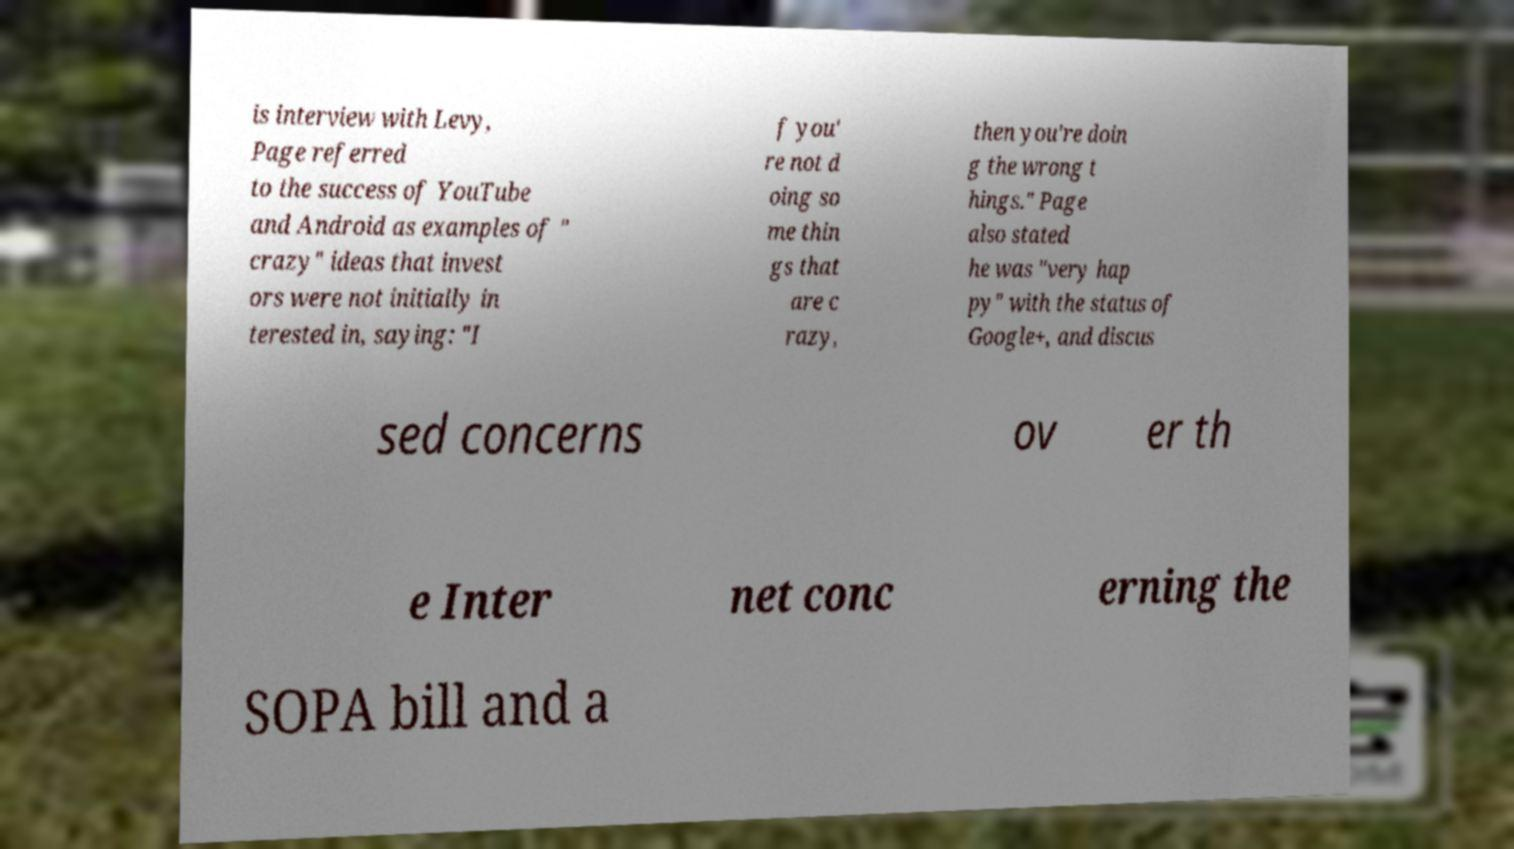Please identify and transcribe the text found in this image. is interview with Levy, Page referred to the success of YouTube and Android as examples of " crazy" ideas that invest ors were not initially in terested in, saying: "I f you' re not d oing so me thin gs that are c razy, then you're doin g the wrong t hings." Page also stated he was "very hap py" with the status of Google+, and discus sed concerns ov er th e Inter net conc erning the SOPA bill and a 